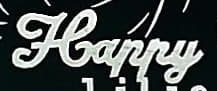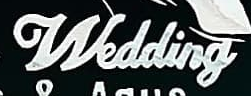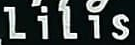Read the text content from these images in order, separated by a semicolon. Happy; Wedding; LiLis 